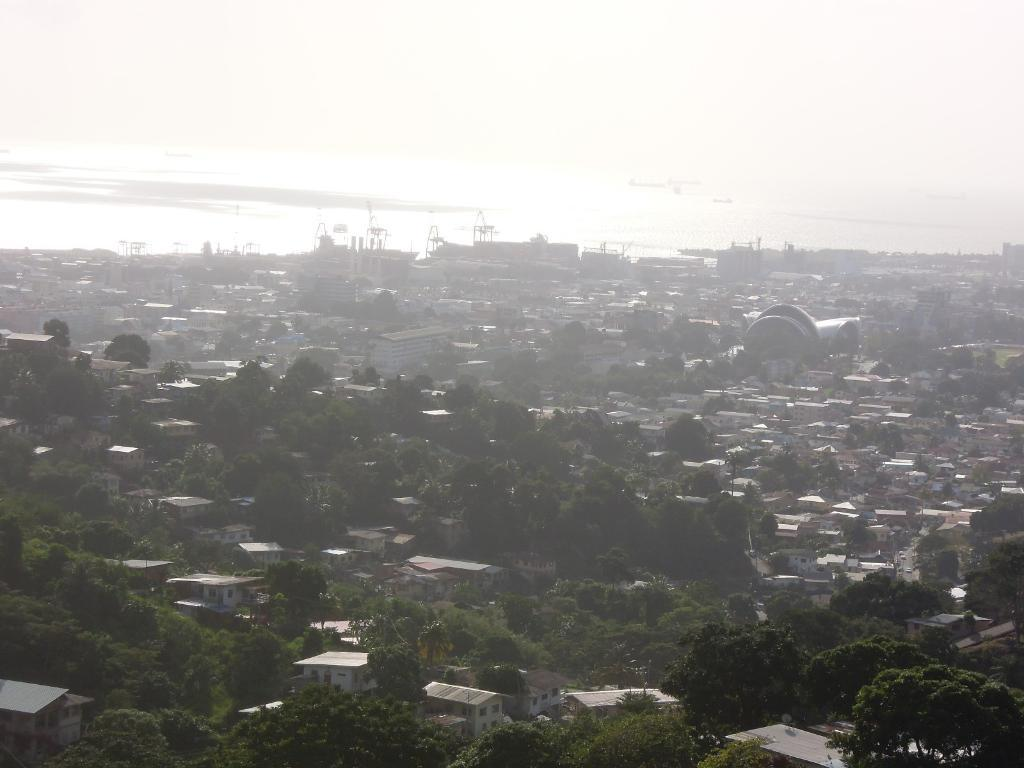What type of natural elements can be seen in the image? There are trees in the image. What type of man-made structures can be seen in the image? There are houses, roofs, buildings, and poles in the image. What architectural features can be seen on the buildings in the image? There are windows in the image. What is present on the water in the image? There are objects on the water in the image. What part of the natural environment is visible in the image? The sky is visible in the image. Where is the field located in the image? There is no field present in the image. What color is the heart in the image? There is no heart present in the image. 